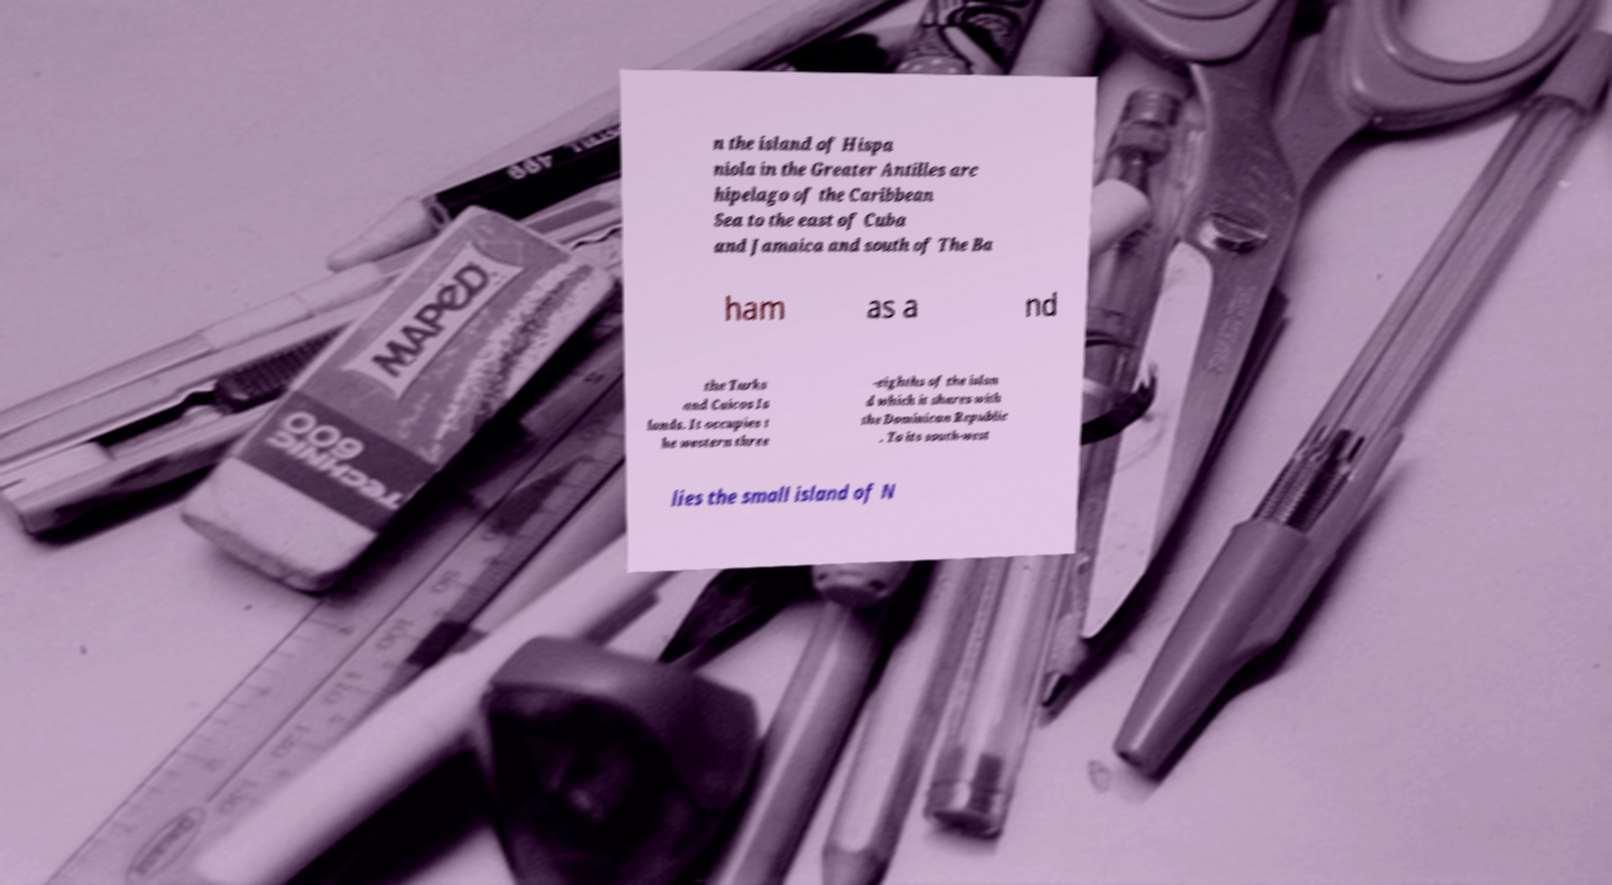Could you extract and type out the text from this image? n the island of Hispa niola in the Greater Antilles arc hipelago of the Caribbean Sea to the east of Cuba and Jamaica and south of The Ba ham as a nd the Turks and Caicos Is lands. It occupies t he western three -eighths of the islan d which it shares with the Dominican Republic . To its south-west lies the small island of N 